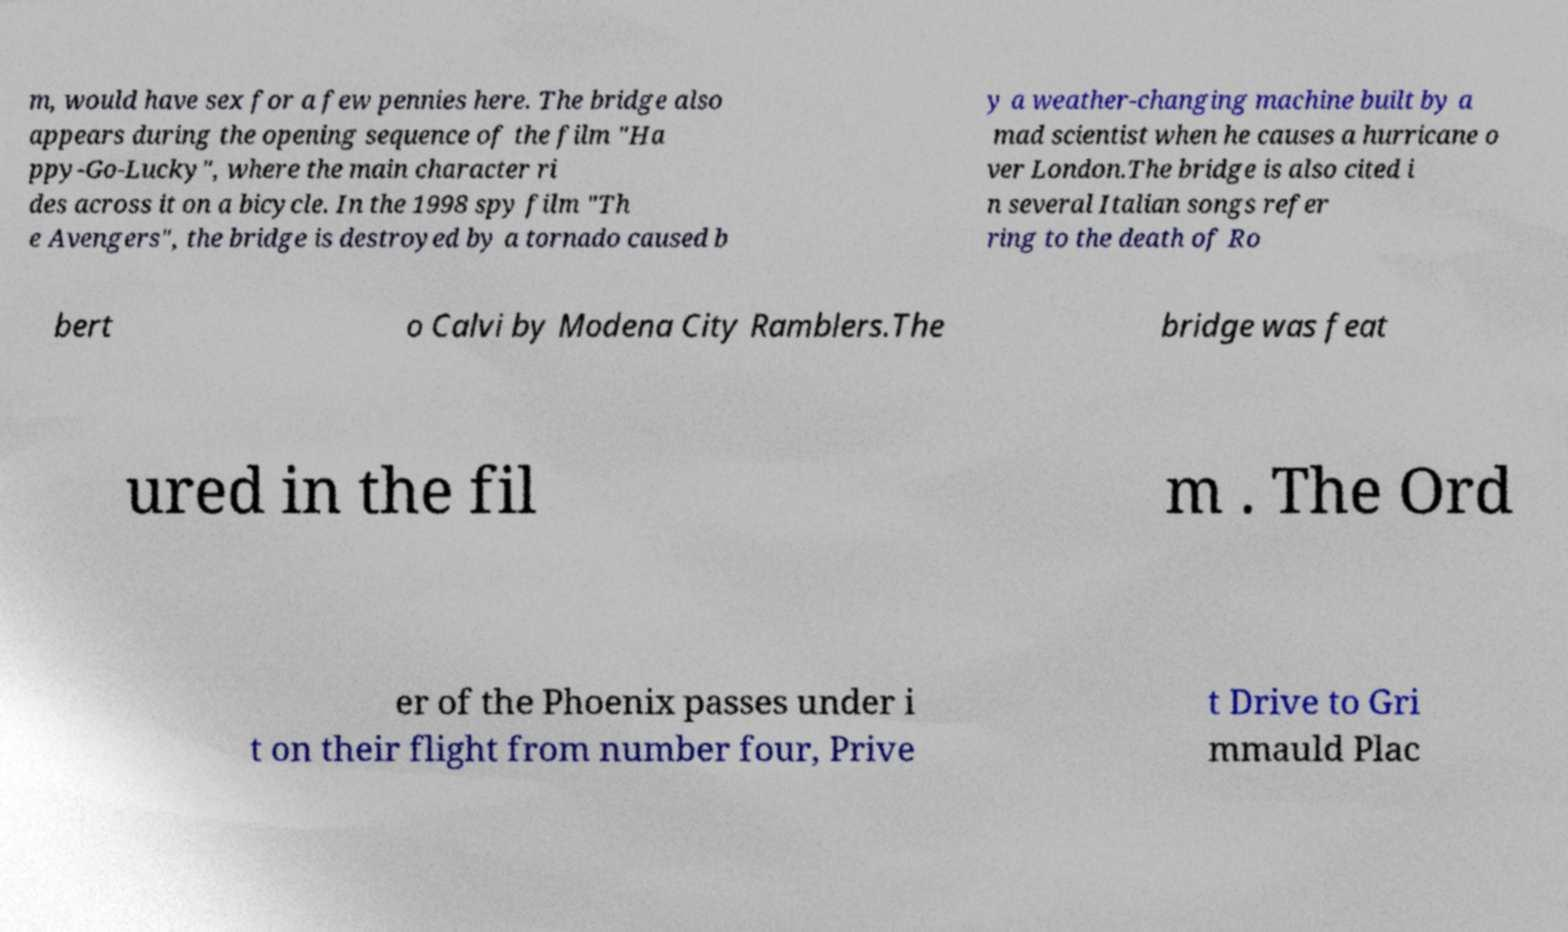I need the written content from this picture converted into text. Can you do that? m, would have sex for a few pennies here. The bridge also appears during the opening sequence of the film "Ha ppy-Go-Lucky", where the main character ri des across it on a bicycle. In the 1998 spy film "Th e Avengers", the bridge is destroyed by a tornado caused b y a weather-changing machine built by a mad scientist when he causes a hurricane o ver London.The bridge is also cited i n several Italian songs refer ring to the death of Ro bert o Calvi by Modena City Ramblers.The bridge was feat ured in the fil m . The Ord er of the Phoenix passes under i t on their flight from number four, Prive t Drive to Gri mmauld Plac 